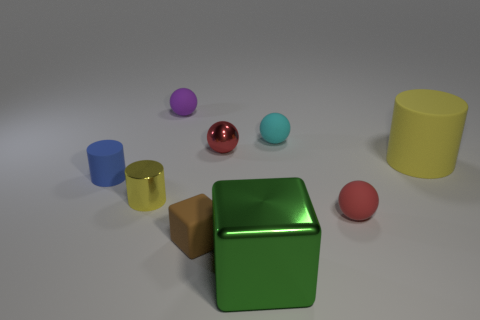Subtract 1 spheres. How many spheres are left? 3 Add 1 purple matte objects. How many objects exist? 10 Subtract all cylinders. How many objects are left? 6 Add 1 red shiny objects. How many red shiny objects are left? 2 Add 9 brown things. How many brown things exist? 10 Subtract 0 gray blocks. How many objects are left? 9 Subtract all small brown metal cylinders. Subtract all brown rubber objects. How many objects are left? 8 